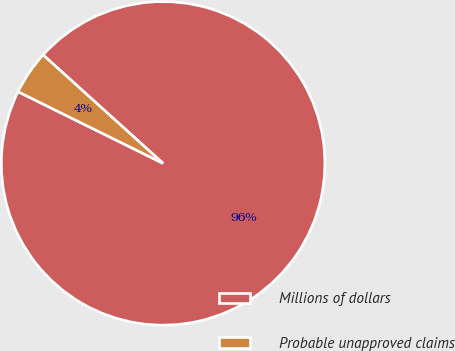Convert chart to OTSL. <chart><loc_0><loc_0><loc_500><loc_500><pie_chart><fcel>Millions of dollars<fcel>Probable unapproved claims<nl><fcel>95.61%<fcel>4.39%<nl></chart> 